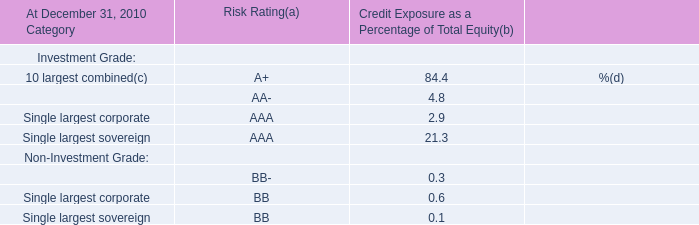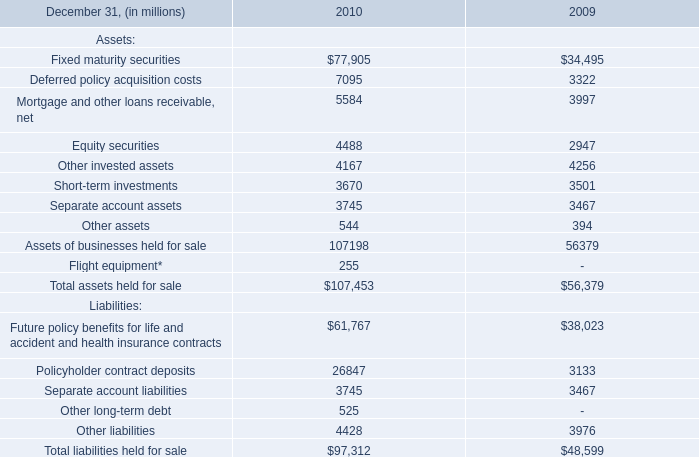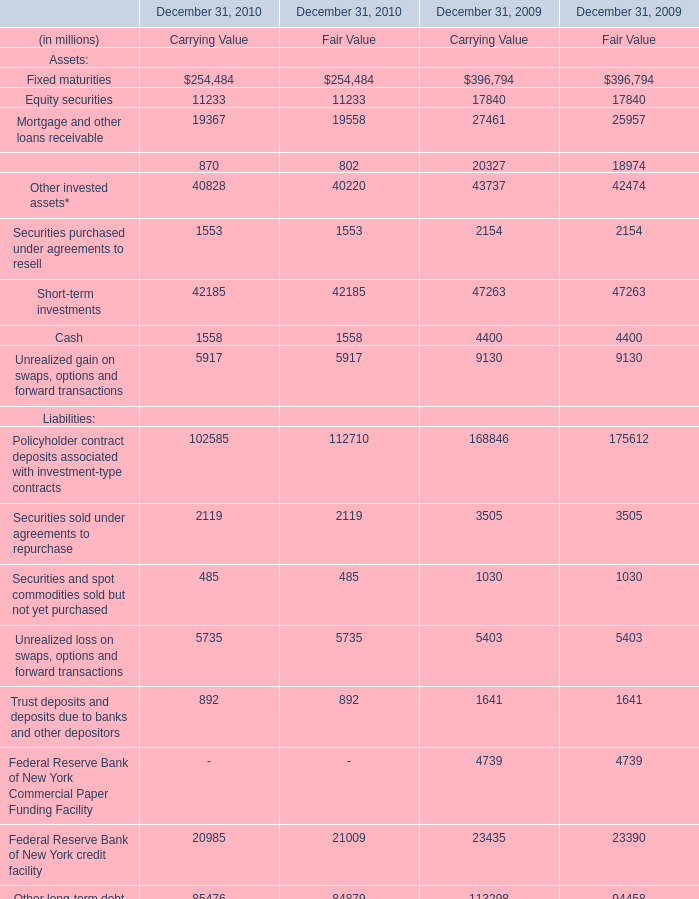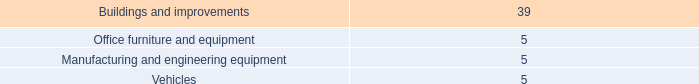What's the average of Equity securities in 2010 and 2009? (in million) 
Computations: ((((11233 + 11233) - 17840) - 17840) / 2)
Answer: -6607.0. 